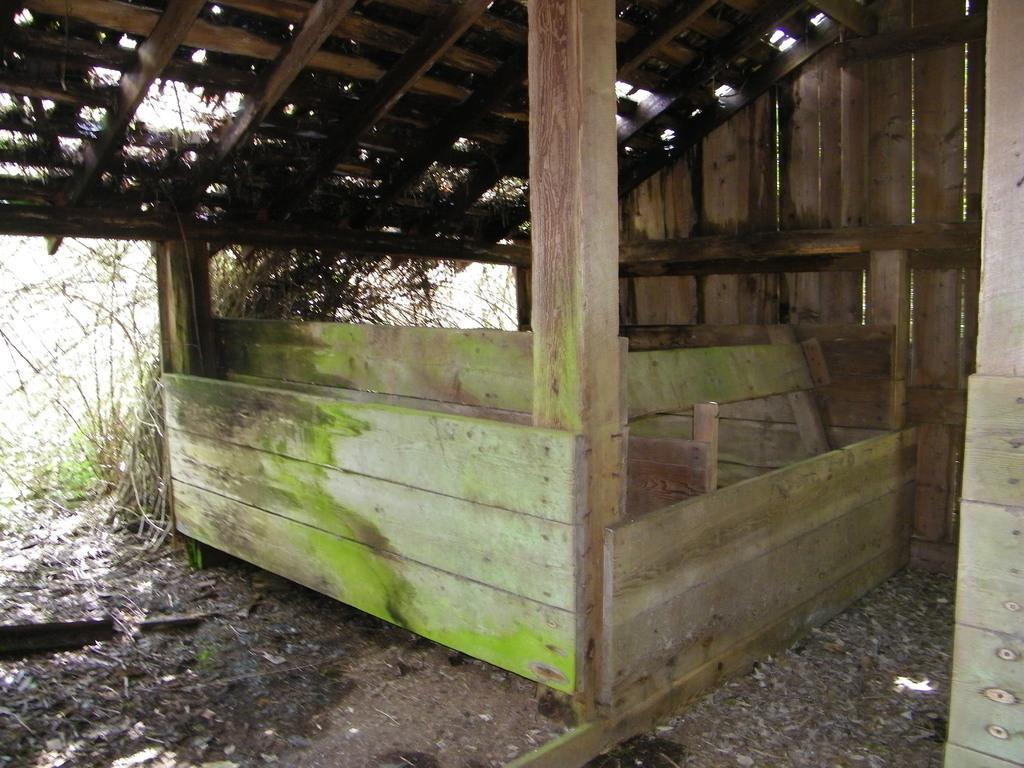What type of structure is present in the image? There is a wooden shed in the image. What type of natural vegetation is visible in the image? There are trees in the image. What is visible on the ground in the image? The ground is visible in the image. What part of the natural environment is visible in the image? The sky is visible in the image. What type of treatment is being applied to the wooden shed in the image? There is no indication in the image that any treatment is being applied to the wooden shed. What type of border is visible around the wooden shed in the image? There is no border visible around the wooden shed in the image. 